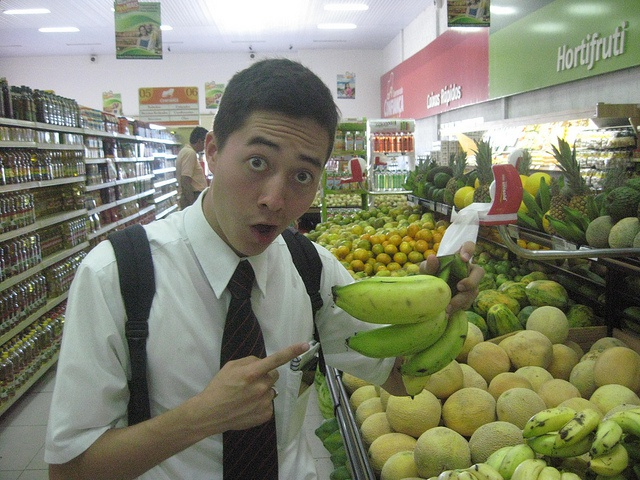Describe the objects in this image and their specific colors. I can see people in gray, darkgray, and black tones, banana in gray, darkgreen, and olive tones, backpack in gray, black, and purple tones, tie in gray and black tones, and banana in gray, darkgreen, olive, and black tones in this image. 